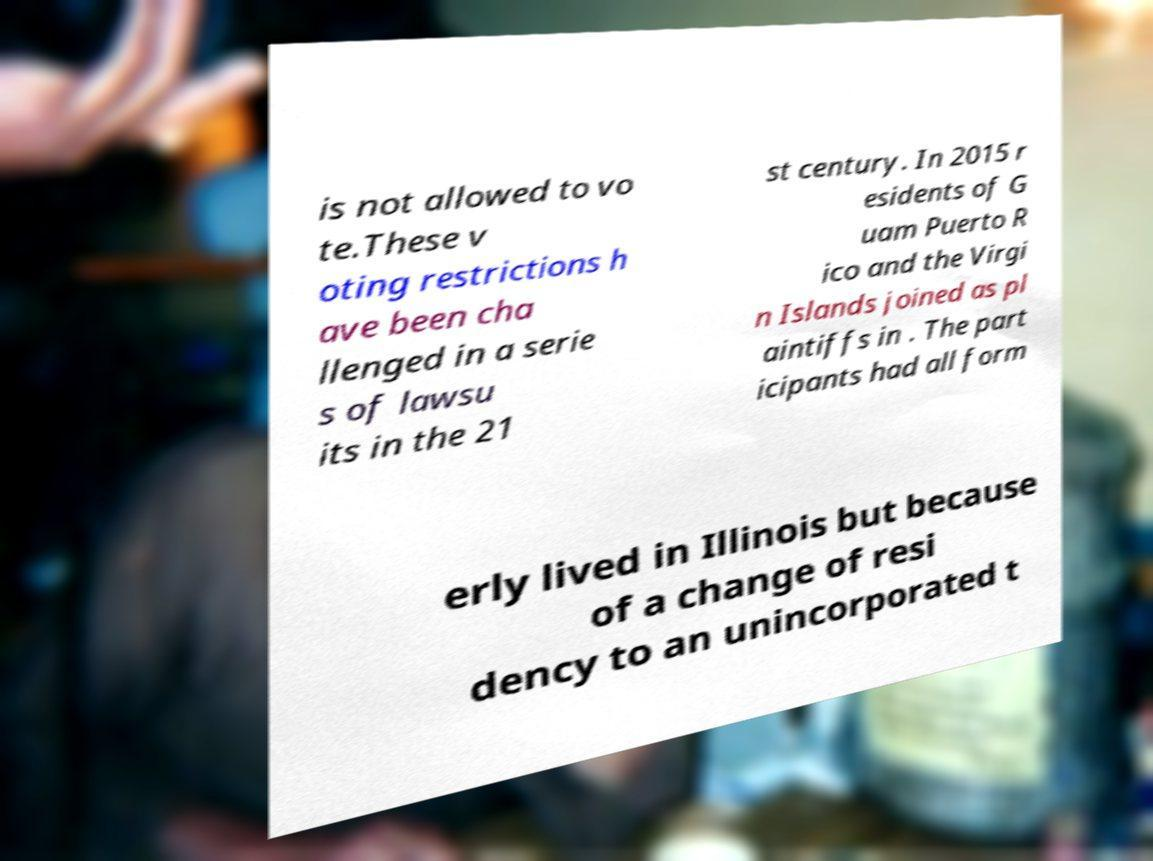Can you accurately transcribe the text from the provided image for me? is not allowed to vo te.These v oting restrictions h ave been cha llenged in a serie s of lawsu its in the 21 st century. In 2015 r esidents of G uam Puerto R ico and the Virgi n Islands joined as pl aintiffs in . The part icipants had all form erly lived in Illinois but because of a change of resi dency to an unincorporated t 